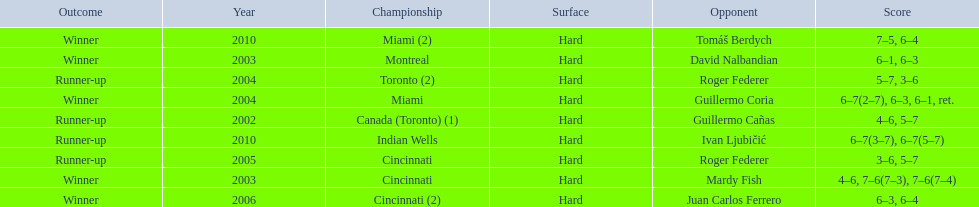What is his highest number of consecutive wins? 3. 